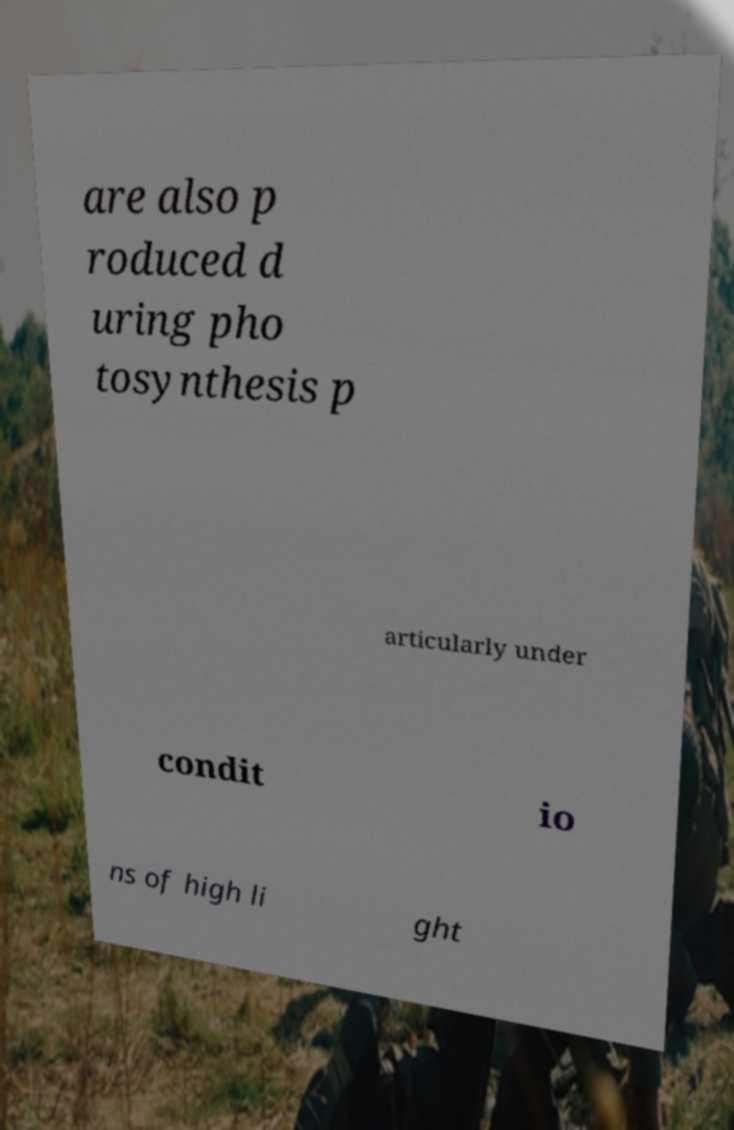Please read and relay the text visible in this image. What does it say? are also p roduced d uring pho tosynthesis p articularly under condit io ns of high li ght 